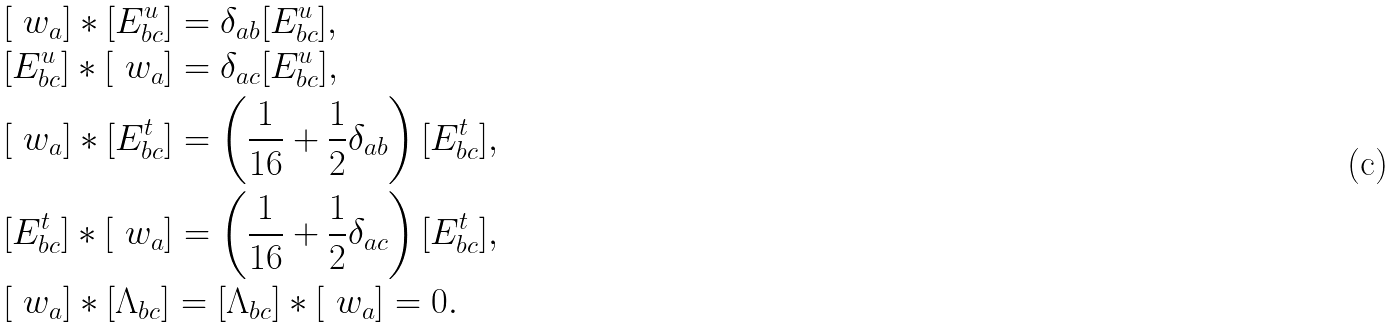<formula> <loc_0><loc_0><loc_500><loc_500>& [ \ w _ { a } ] * [ E ^ { u } _ { b c } ] = \delta _ { a b } [ E ^ { u } _ { b c } ] , \\ & [ E ^ { u } _ { b c } ] * [ \ w _ { a } ] = \delta _ { a c } [ E ^ { u } _ { b c } ] , \\ & [ \ w _ { a } ] * [ E ^ { t } _ { b c } ] = \left ( \frac { 1 } { 1 6 } + \frac { 1 } { 2 } \delta _ { a b } \right ) [ E ^ { t } _ { b c } ] , \\ & [ E ^ { t } _ { b c } ] * [ \ w _ { a } ] = \left ( \frac { 1 } { 1 6 } + \frac { 1 } { 2 } \delta _ { a c } \right ) [ E ^ { t } _ { b c } ] , \\ & [ \ w _ { a } ] * [ \Lambda _ { b c } ] = [ \Lambda _ { b c } ] * [ \ w _ { a } ] = 0 .</formula> 